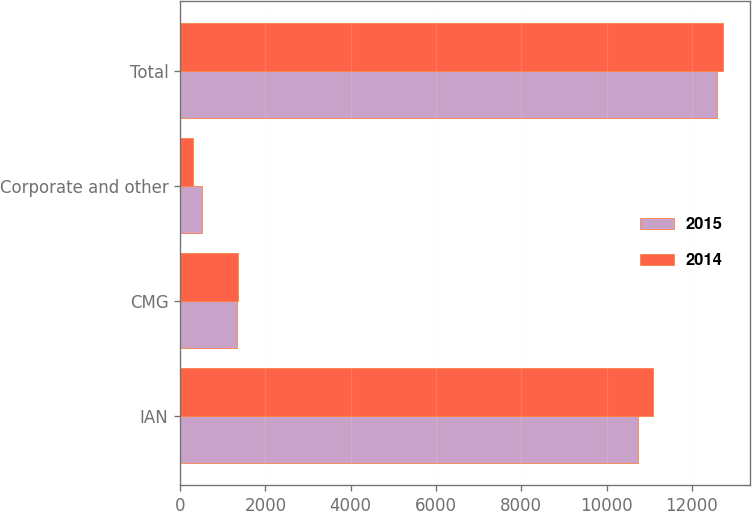Convert chart. <chart><loc_0><loc_0><loc_500><loc_500><stacked_bar_chart><ecel><fcel>IAN<fcel>CMG<fcel>Corporate and other<fcel>Total<nl><fcel>2015<fcel>10738.2<fcel>1338.6<fcel>508.3<fcel>12585.1<nl><fcel>2014<fcel>11080.2<fcel>1347.5<fcel>308.9<fcel>12736.6<nl></chart> 